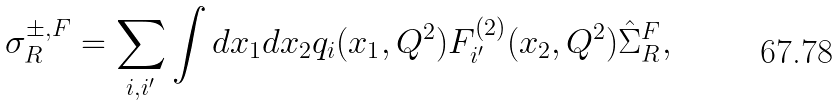Convert formula to latex. <formula><loc_0><loc_0><loc_500><loc_500>\sigma ^ { \pm , F } _ { R } = \sum _ { i , i ^ { \prime } } \int d x _ { 1 } d x _ { 2 } q _ { i } ( x _ { 1 } , Q ^ { 2 } ) F _ { i ^ { \prime } } ^ { ( 2 ) } ( x _ { 2 } , Q ^ { 2 } ) { \hat { \Sigma } } ^ { F } _ { R } ,</formula> 